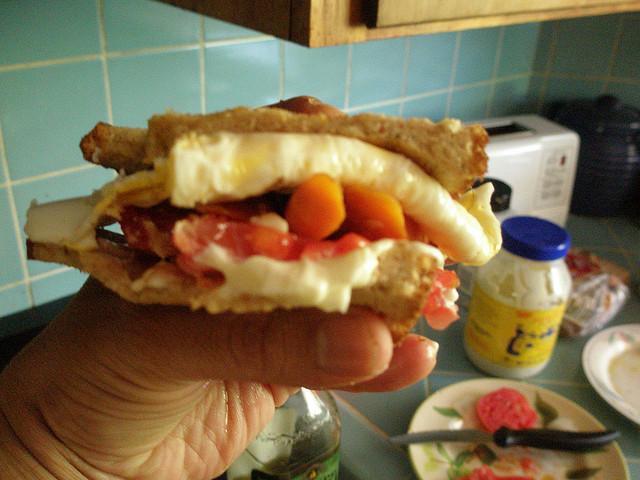Is "The sandwich is in front of the toaster." an appropriate description for the image?
Answer yes or no. Yes. Does the caption "The sandwich is near the toaster." correctly depict the image?
Answer yes or no. Yes. Verify the accuracy of this image caption: "The toaster is near the sandwich.".
Answer yes or no. Yes. Verify the accuracy of this image caption: "The person is touching the sandwich.".
Answer yes or no. Yes. Does the image validate the caption "The person is touching the toaster."?
Answer yes or no. No. 